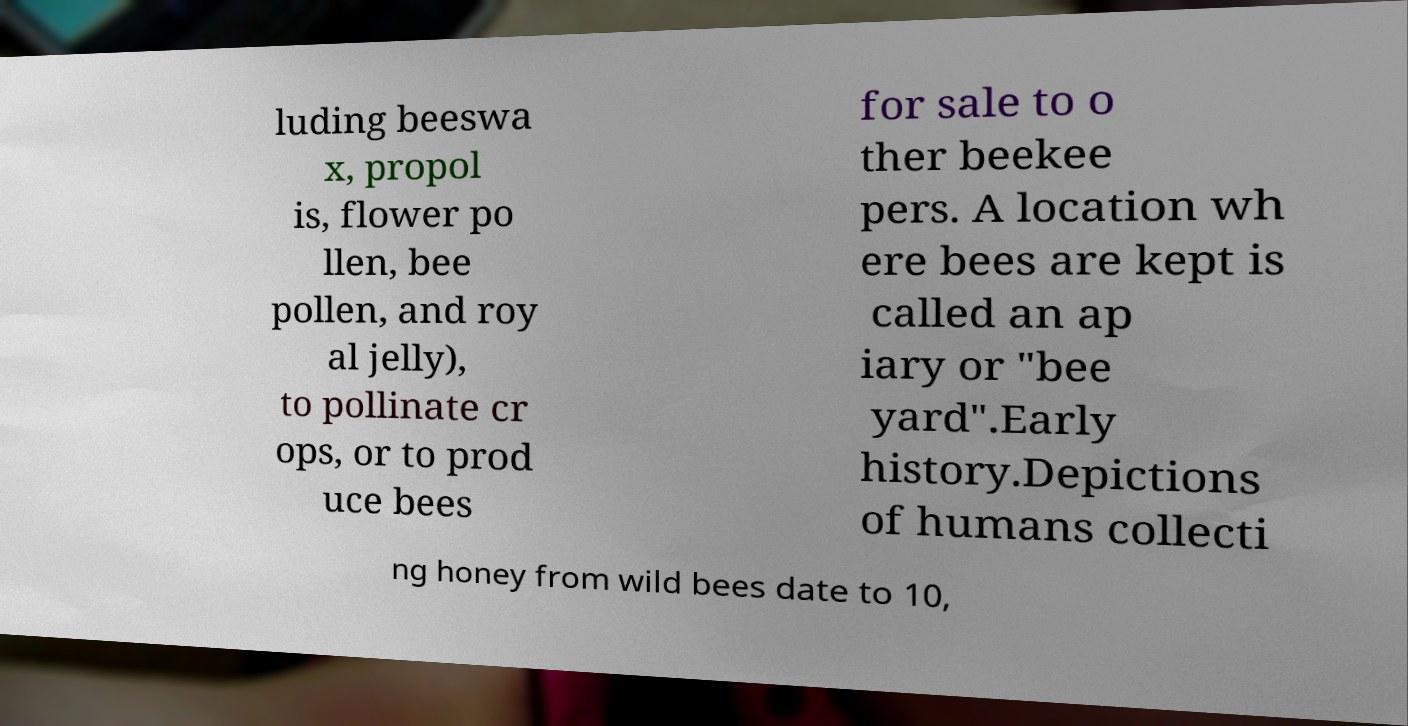For documentation purposes, I need the text within this image transcribed. Could you provide that? luding beeswa x, propol is, flower po llen, bee pollen, and roy al jelly), to pollinate cr ops, or to prod uce bees for sale to o ther beekee pers. A location wh ere bees are kept is called an ap iary or "bee yard".Early history.Depictions of humans collecti ng honey from wild bees date to 10, 